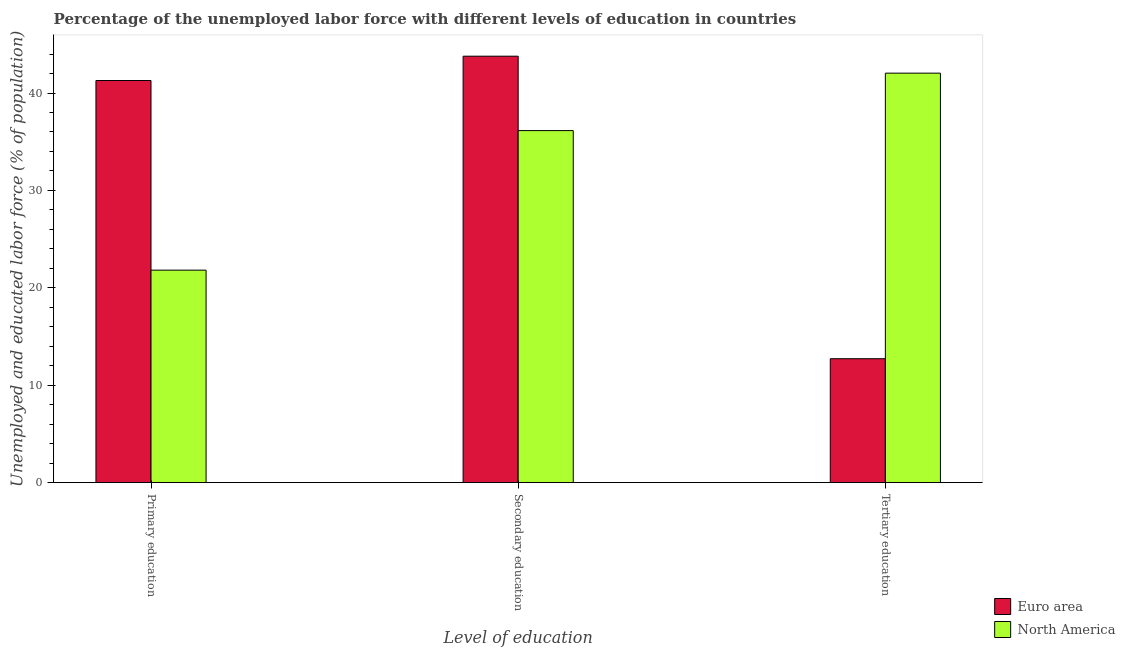How many different coloured bars are there?
Your answer should be very brief. 2. How many bars are there on the 3rd tick from the left?
Your answer should be very brief. 2. How many bars are there on the 3rd tick from the right?
Provide a short and direct response. 2. What is the label of the 3rd group of bars from the left?
Give a very brief answer. Tertiary education. What is the percentage of labor force who received tertiary education in Euro area?
Keep it short and to the point. 12.72. Across all countries, what is the maximum percentage of labor force who received primary education?
Your response must be concise. 41.29. Across all countries, what is the minimum percentage of labor force who received tertiary education?
Make the answer very short. 12.72. In which country was the percentage of labor force who received secondary education maximum?
Make the answer very short. Euro area. What is the total percentage of labor force who received primary education in the graph?
Give a very brief answer. 63.1. What is the difference between the percentage of labor force who received primary education in Euro area and that in North America?
Give a very brief answer. 19.47. What is the difference between the percentage of labor force who received tertiary education in Euro area and the percentage of labor force who received secondary education in North America?
Your answer should be very brief. -23.42. What is the average percentage of labor force who received secondary education per country?
Provide a succinct answer. 39.96. What is the difference between the percentage of labor force who received primary education and percentage of labor force who received secondary education in North America?
Give a very brief answer. -14.33. In how many countries, is the percentage of labor force who received primary education greater than 28 %?
Ensure brevity in your answer.  1. What is the ratio of the percentage of labor force who received secondary education in Euro area to that in North America?
Ensure brevity in your answer.  1.21. What is the difference between the highest and the second highest percentage of labor force who received tertiary education?
Offer a terse response. 29.32. What is the difference between the highest and the lowest percentage of labor force who received primary education?
Ensure brevity in your answer.  19.47. In how many countries, is the percentage of labor force who received tertiary education greater than the average percentage of labor force who received tertiary education taken over all countries?
Keep it short and to the point. 1. What does the 2nd bar from the left in Tertiary education represents?
Provide a succinct answer. North America. Is it the case that in every country, the sum of the percentage of labor force who received primary education and percentage of labor force who received secondary education is greater than the percentage of labor force who received tertiary education?
Ensure brevity in your answer.  Yes. How many bars are there?
Ensure brevity in your answer.  6. How many countries are there in the graph?
Your response must be concise. 2. What is the difference between two consecutive major ticks on the Y-axis?
Your response must be concise. 10. Are the values on the major ticks of Y-axis written in scientific E-notation?
Keep it short and to the point. No. Does the graph contain any zero values?
Offer a very short reply. No. How many legend labels are there?
Ensure brevity in your answer.  2. How are the legend labels stacked?
Make the answer very short. Vertical. What is the title of the graph?
Your answer should be very brief. Percentage of the unemployed labor force with different levels of education in countries. Does "Marshall Islands" appear as one of the legend labels in the graph?
Your response must be concise. No. What is the label or title of the X-axis?
Offer a terse response. Level of education. What is the label or title of the Y-axis?
Provide a succinct answer. Unemployed and educated labor force (% of population). What is the Unemployed and educated labor force (% of population) in Euro area in Primary education?
Provide a succinct answer. 41.29. What is the Unemployed and educated labor force (% of population) in North America in Primary education?
Your answer should be compact. 21.81. What is the Unemployed and educated labor force (% of population) of Euro area in Secondary education?
Your answer should be very brief. 43.78. What is the Unemployed and educated labor force (% of population) of North America in Secondary education?
Offer a very short reply. 36.14. What is the Unemployed and educated labor force (% of population) in Euro area in Tertiary education?
Your answer should be very brief. 12.72. What is the Unemployed and educated labor force (% of population) of North America in Tertiary education?
Give a very brief answer. 42.04. Across all Level of education, what is the maximum Unemployed and educated labor force (% of population) of Euro area?
Offer a very short reply. 43.78. Across all Level of education, what is the maximum Unemployed and educated labor force (% of population) in North America?
Provide a succinct answer. 42.04. Across all Level of education, what is the minimum Unemployed and educated labor force (% of population) of Euro area?
Make the answer very short. 12.72. Across all Level of education, what is the minimum Unemployed and educated labor force (% of population) in North America?
Offer a very short reply. 21.81. What is the total Unemployed and educated labor force (% of population) of Euro area in the graph?
Make the answer very short. 97.79. What is the difference between the Unemployed and educated labor force (% of population) of Euro area in Primary education and that in Secondary education?
Keep it short and to the point. -2.5. What is the difference between the Unemployed and educated labor force (% of population) in North America in Primary education and that in Secondary education?
Keep it short and to the point. -14.33. What is the difference between the Unemployed and educated labor force (% of population) in Euro area in Primary education and that in Tertiary education?
Provide a succinct answer. 28.57. What is the difference between the Unemployed and educated labor force (% of population) of North America in Primary education and that in Tertiary education?
Give a very brief answer. -20.23. What is the difference between the Unemployed and educated labor force (% of population) of Euro area in Secondary education and that in Tertiary education?
Your answer should be compact. 31.06. What is the difference between the Unemployed and educated labor force (% of population) in North America in Secondary education and that in Tertiary education?
Offer a terse response. -5.9. What is the difference between the Unemployed and educated labor force (% of population) in Euro area in Primary education and the Unemployed and educated labor force (% of population) in North America in Secondary education?
Offer a terse response. 5.14. What is the difference between the Unemployed and educated labor force (% of population) in Euro area in Primary education and the Unemployed and educated labor force (% of population) in North America in Tertiary education?
Your answer should be very brief. -0.76. What is the difference between the Unemployed and educated labor force (% of population) of Euro area in Secondary education and the Unemployed and educated labor force (% of population) of North America in Tertiary education?
Provide a short and direct response. 1.74. What is the average Unemployed and educated labor force (% of population) of Euro area per Level of education?
Provide a short and direct response. 32.6. What is the average Unemployed and educated labor force (% of population) in North America per Level of education?
Ensure brevity in your answer.  33.33. What is the difference between the Unemployed and educated labor force (% of population) of Euro area and Unemployed and educated labor force (% of population) of North America in Primary education?
Offer a terse response. 19.47. What is the difference between the Unemployed and educated labor force (% of population) in Euro area and Unemployed and educated labor force (% of population) in North America in Secondary education?
Give a very brief answer. 7.64. What is the difference between the Unemployed and educated labor force (% of population) in Euro area and Unemployed and educated labor force (% of population) in North America in Tertiary education?
Give a very brief answer. -29.32. What is the ratio of the Unemployed and educated labor force (% of population) in Euro area in Primary education to that in Secondary education?
Your answer should be very brief. 0.94. What is the ratio of the Unemployed and educated labor force (% of population) in North America in Primary education to that in Secondary education?
Make the answer very short. 0.6. What is the ratio of the Unemployed and educated labor force (% of population) of Euro area in Primary education to that in Tertiary education?
Your answer should be very brief. 3.25. What is the ratio of the Unemployed and educated labor force (% of population) in North America in Primary education to that in Tertiary education?
Make the answer very short. 0.52. What is the ratio of the Unemployed and educated labor force (% of population) in Euro area in Secondary education to that in Tertiary education?
Give a very brief answer. 3.44. What is the ratio of the Unemployed and educated labor force (% of population) of North America in Secondary education to that in Tertiary education?
Keep it short and to the point. 0.86. What is the difference between the highest and the second highest Unemployed and educated labor force (% of population) of Euro area?
Your response must be concise. 2.5. What is the difference between the highest and the second highest Unemployed and educated labor force (% of population) in North America?
Make the answer very short. 5.9. What is the difference between the highest and the lowest Unemployed and educated labor force (% of population) in Euro area?
Provide a succinct answer. 31.06. What is the difference between the highest and the lowest Unemployed and educated labor force (% of population) of North America?
Offer a terse response. 20.23. 